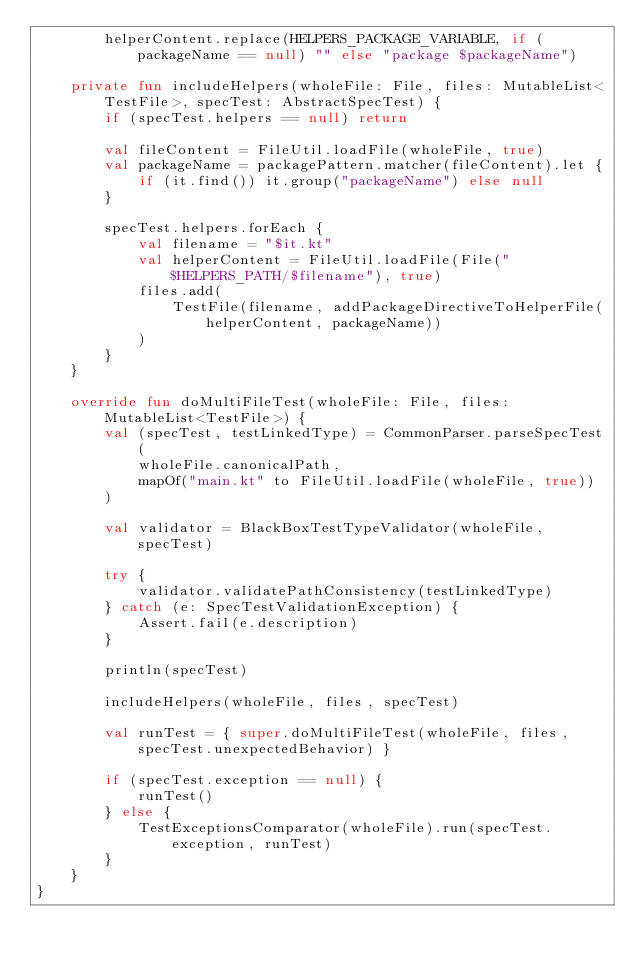<code> <loc_0><loc_0><loc_500><loc_500><_Kotlin_>        helperContent.replace(HELPERS_PACKAGE_VARIABLE, if (packageName == null) "" else "package $packageName")

    private fun includeHelpers(wholeFile: File, files: MutableList<TestFile>, specTest: AbstractSpecTest) {
        if (specTest.helpers == null) return

        val fileContent = FileUtil.loadFile(wholeFile, true)
        val packageName = packagePattern.matcher(fileContent).let {
            if (it.find()) it.group("packageName") else null
        }

        specTest.helpers.forEach {
            val filename = "$it.kt"
            val helperContent = FileUtil.loadFile(File("$HELPERS_PATH/$filename"), true)
            files.add(
                TestFile(filename, addPackageDirectiveToHelperFile(helperContent, packageName))
            )
        }
    }

    override fun doMultiFileTest(wholeFile: File, files: MutableList<TestFile>) {
        val (specTest, testLinkedType) = CommonParser.parseSpecTest(
            wholeFile.canonicalPath,
            mapOf("main.kt" to FileUtil.loadFile(wholeFile, true))
        )

        val validator = BlackBoxTestTypeValidator(wholeFile, specTest)

        try {
            validator.validatePathConsistency(testLinkedType)
        } catch (e: SpecTestValidationException) {
            Assert.fail(e.description)
        }

        println(specTest)

        includeHelpers(wholeFile, files, specTest)

        val runTest = { super.doMultiFileTest(wholeFile, files, specTest.unexpectedBehavior) }

        if (specTest.exception == null) {
            runTest()
        } else {
            TestExceptionsComparator(wholeFile).run(specTest.exception, runTest)
        }
    }
}
</code> 